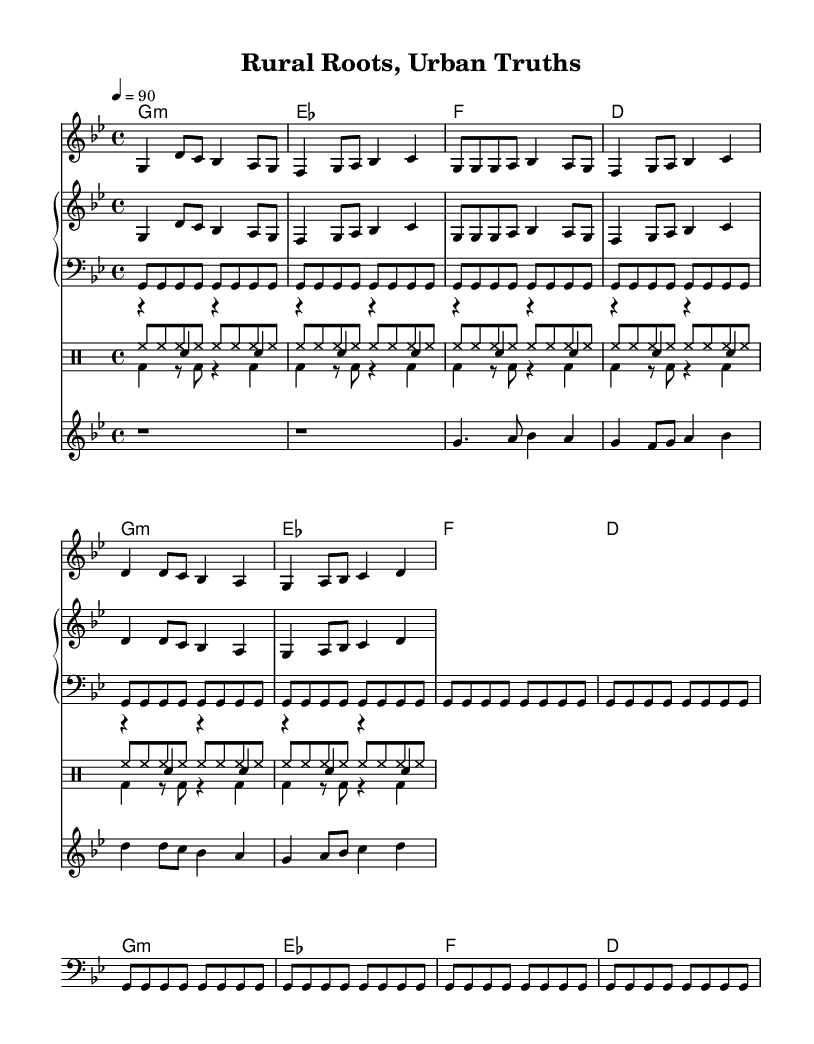what is the key signature of this music? The key signature is G minor, which is indicated by the presence of B flat. In the initial part of the global section, the key signature is set to G minor corresponding to the flat notes present.
Answer: G minor what is the time signature of this music? The time signature displayed is 4/4, which indicates there are four beats in each measure, and the quarter note gets one beat. This can be found in the global section where the time signature is defined.
Answer: 4/4 what is the tempo of the music? The tempo is marked as 90 beats per minute, which is set in the global section to provide guidance for the performance speed.
Answer: 90 how many measures are in the verse section? There are 4 measures in the verse section, as each fragment of the 'melody' shows 4 groups of notes corresponding to it. Counting from the verse part provided in the music shows this.
Answer: 4 what instruments are included in this music score? The instruments included are Violin, Bass, Drums (Hi-Hat, Kick, Snare), and Piano (upper and lower). This information can be deduced from the staff notations and labels present in the score layout.
Answer: Violin, Bass, Drums, Piano what is the lyrical theme of the chorus? The lyrical theme of the chorus discusses the juxtaposition of rural and urban struggles, emphasizing divided families facing hardships. This can be derived from the lyrics presented in the context of rural migration and its societal impact.
Answer: Rural roots, urban truths 